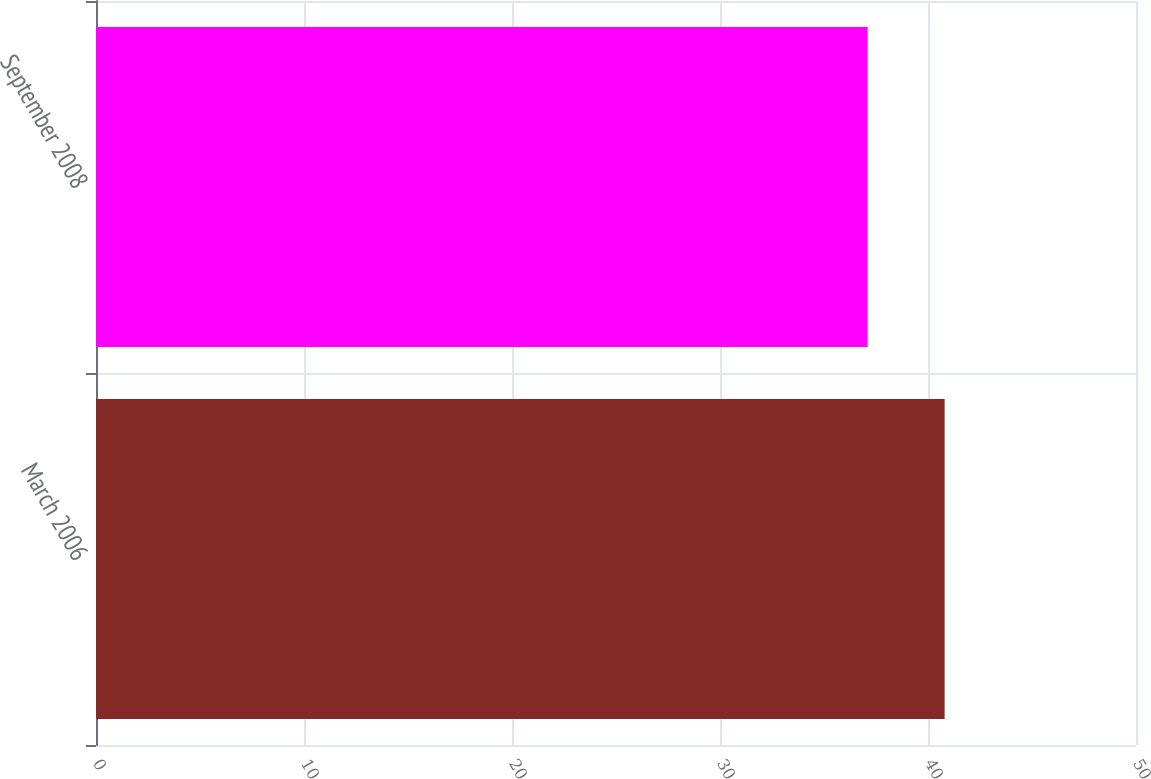Convert chart. <chart><loc_0><loc_0><loc_500><loc_500><bar_chart><fcel>March 2006<fcel>September 2008<nl><fcel>40.8<fcel>37.1<nl></chart> 